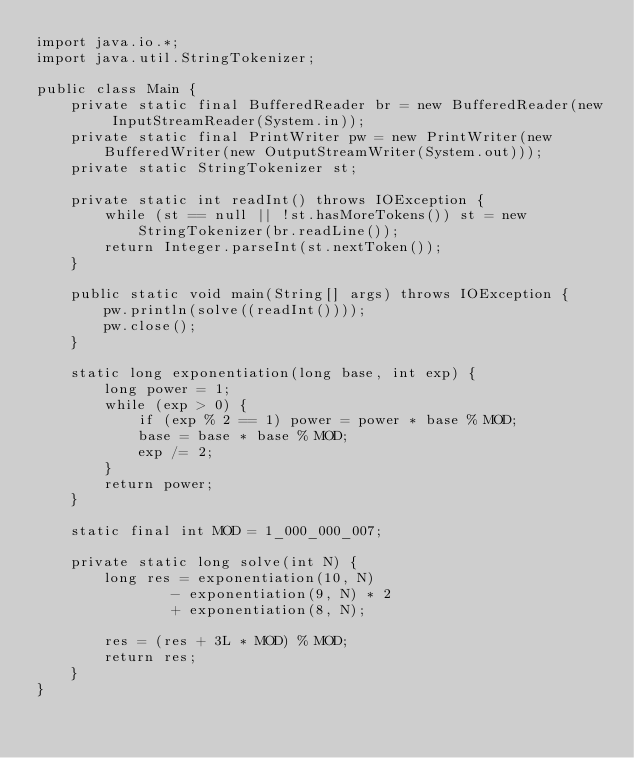Convert code to text. <code><loc_0><loc_0><loc_500><loc_500><_Java_>import java.io.*;
import java.util.StringTokenizer;

public class Main {
    private static final BufferedReader br = new BufferedReader(new InputStreamReader(System.in));
    private static final PrintWriter pw = new PrintWriter(new BufferedWriter(new OutputStreamWriter(System.out)));
    private static StringTokenizer st;

    private static int readInt() throws IOException {
        while (st == null || !st.hasMoreTokens()) st = new StringTokenizer(br.readLine());
        return Integer.parseInt(st.nextToken());
    }

    public static void main(String[] args) throws IOException {
        pw.println(solve((readInt())));
        pw.close();
    }

    static long exponentiation(long base, int exp) {
        long power = 1;
        while (exp > 0) {
            if (exp % 2 == 1) power = power * base % MOD;
            base = base * base % MOD;
            exp /= 2;
        }
        return power;
    }

    static final int MOD = 1_000_000_007;

    private static long solve(int N) {
        long res = exponentiation(10, N)
                - exponentiation(9, N) * 2
                + exponentiation(8, N);

        res = (res + 3L * MOD) % MOD;
        return res;
    }
}</code> 